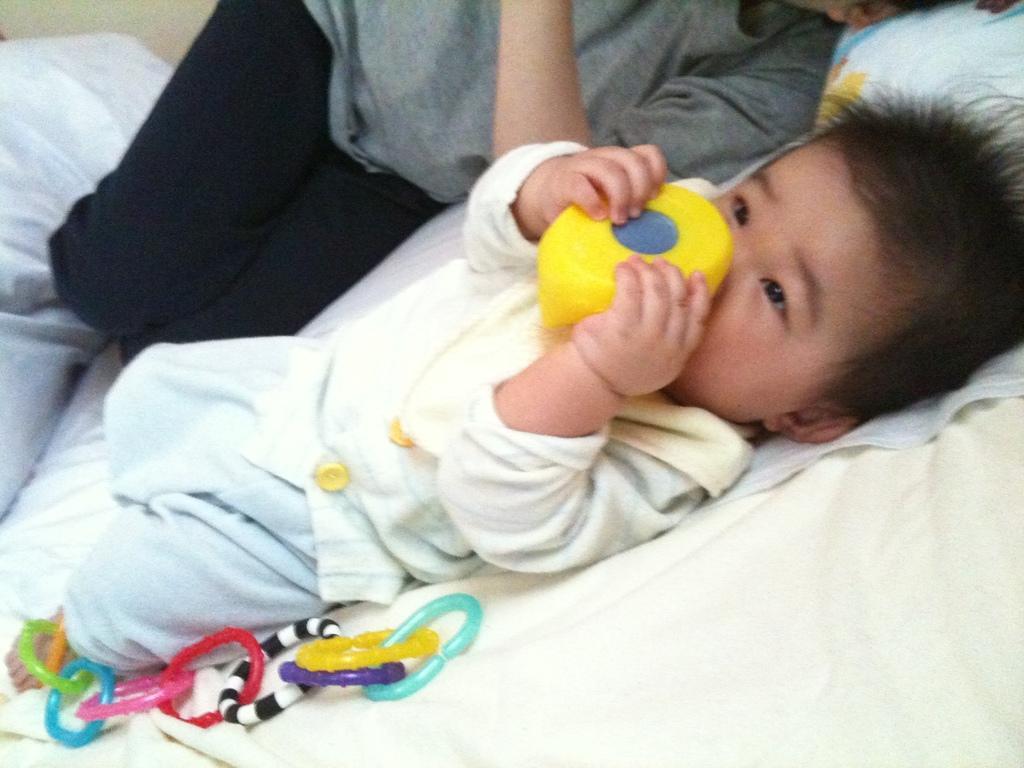Please provide a concise description of this image. In this picture we can see a baby boy,person lying on the bed. 